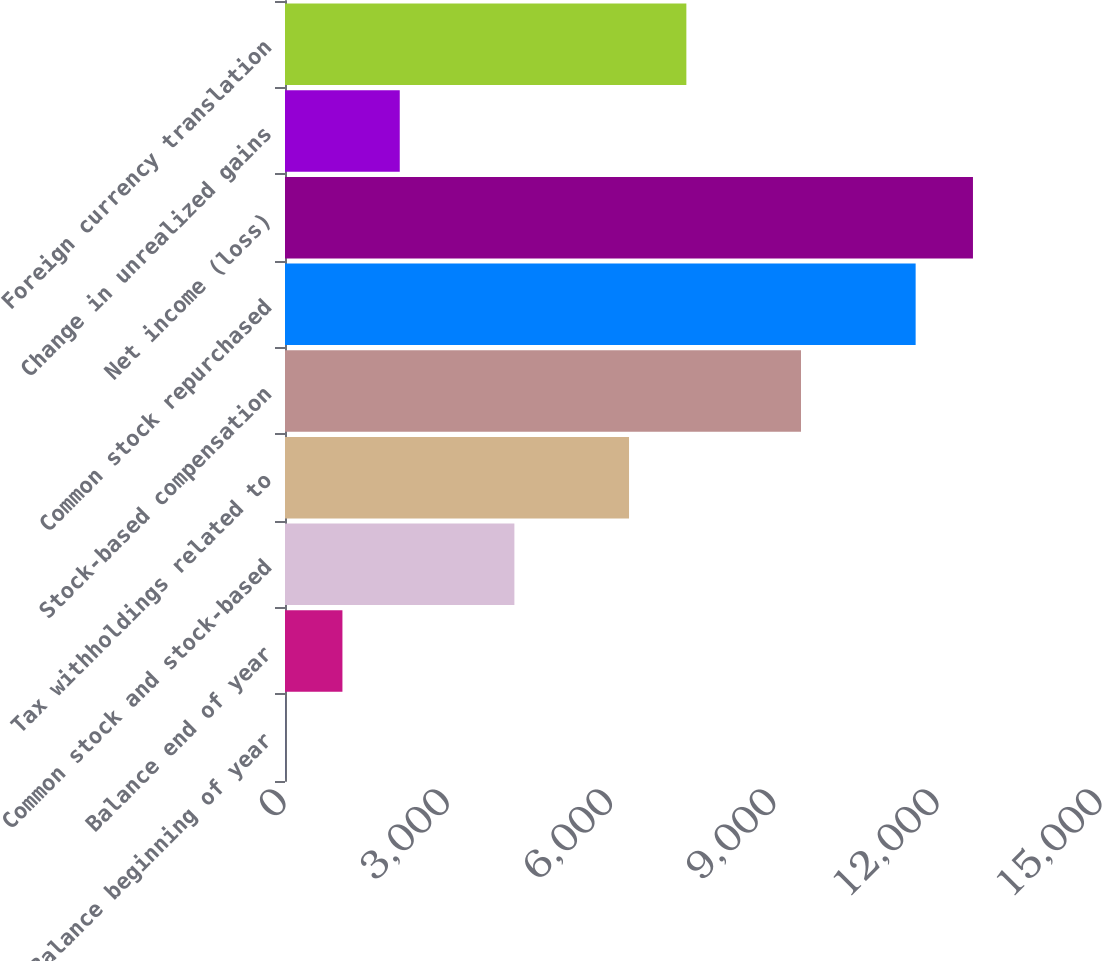Convert chart to OTSL. <chart><loc_0><loc_0><loc_500><loc_500><bar_chart><fcel>Balance beginning of year<fcel>Balance end of year<fcel>Common stock and stock-based<fcel>Tax withholdings related to<fcel>Stock-based compensation<fcel>Common stock repurchased<fcel>Net income (loss)<fcel>Change in unrealized gains<fcel>Foreign currency translation<nl><fcel>2<fcel>1055.7<fcel>4216.8<fcel>6324.2<fcel>9485.3<fcel>11592.7<fcel>12646.4<fcel>2109.4<fcel>7377.9<nl></chart> 